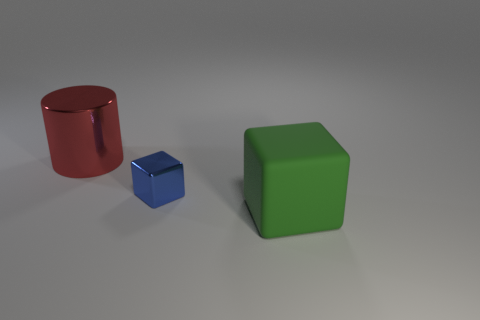Add 3 blue metallic objects. How many objects exist? 6 Subtract all blocks. How many objects are left? 1 Add 2 large things. How many large things are left? 4 Add 1 blue things. How many blue things exist? 2 Subtract 0 green spheres. How many objects are left? 3 Subtract all green matte blocks. Subtract all green rubber blocks. How many objects are left? 1 